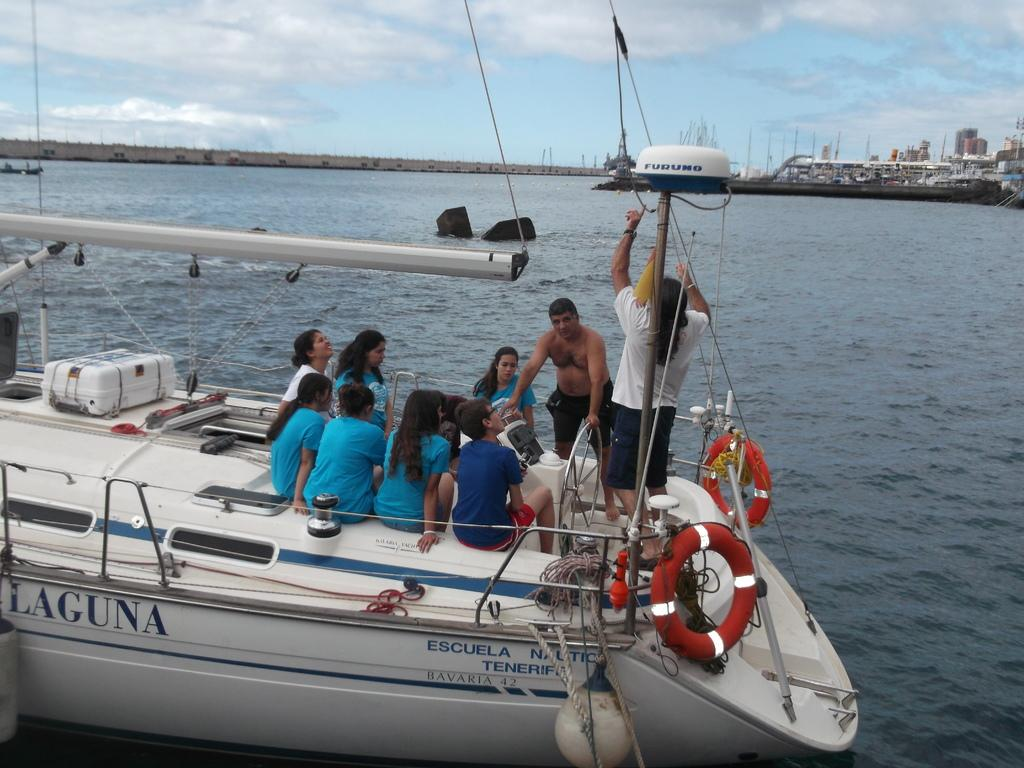<image>
Summarize the visual content of the image. several people on a boat that has laguna on side and someone pointing at wite thing on a pole labeled furuno 